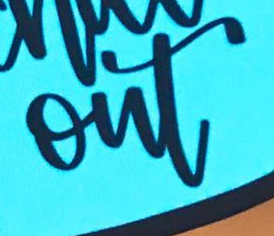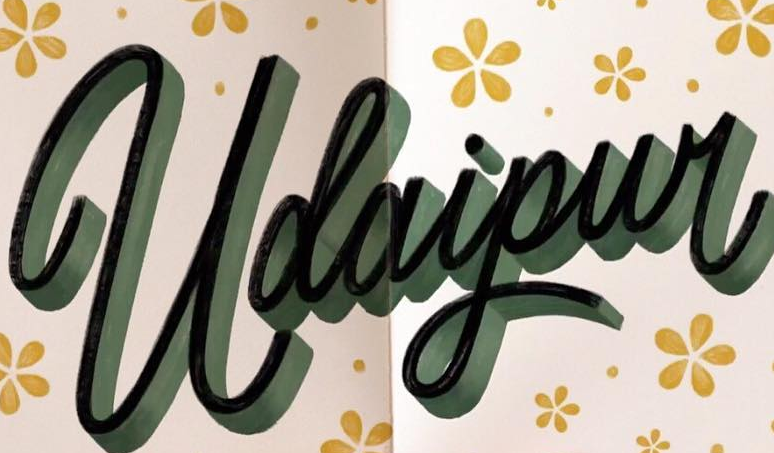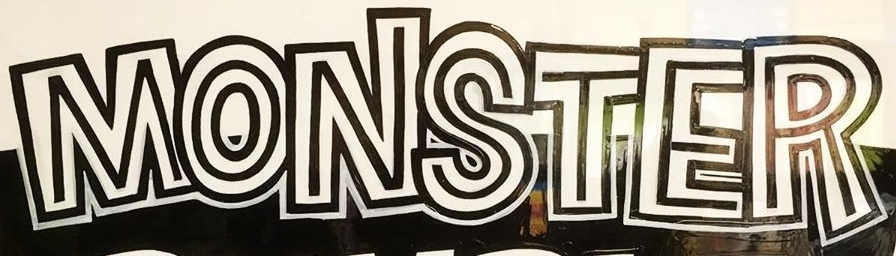What text is displayed in these images sequentially, separated by a semicolon? out; Udaipur; MONSTER 